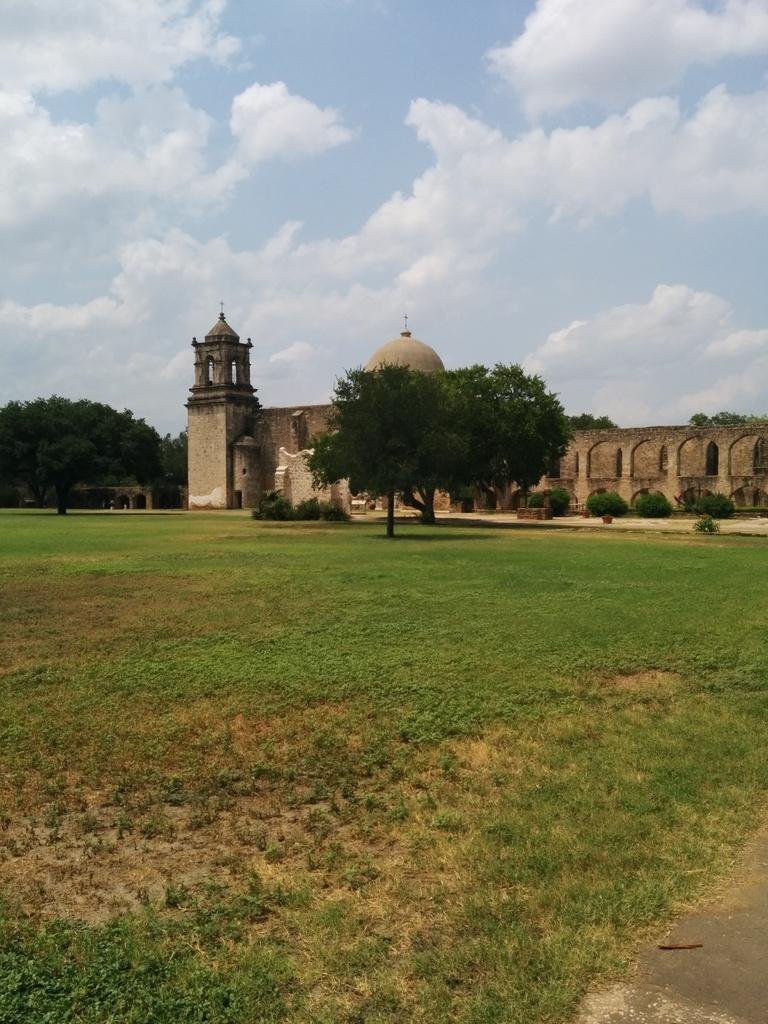What is the main subject of the image? There is a monument in the image. What is in front of the monument? There is a wall, grass, plants, and trees in front of the monument. Are there any trees visible behind the monument? Yes, trees are visible behind the monument. What is visible at the top of the image? The sky is visible at the top of the image. What advice does the rod give to the achiever in the image? There is no rod or achiever present in the image, so it is not possible to answer that question. 